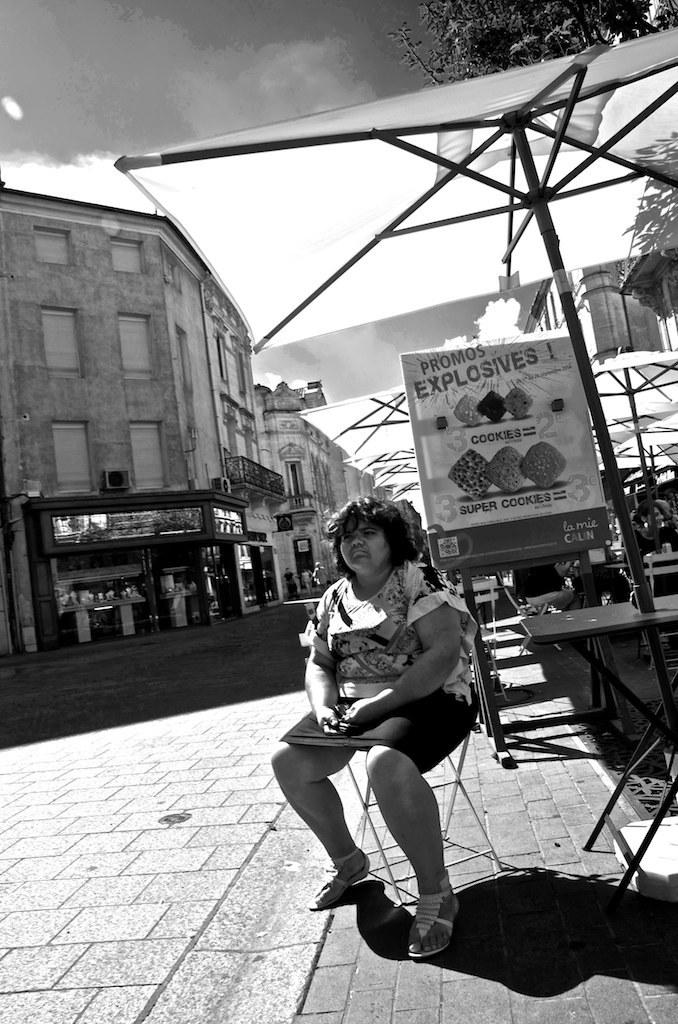What is the lady in the image doing? The lady is sitting on a chair in the image. What can be seen in the background of the image? There are banners, tents, buildings, tables and chairs, and trees in the background of the image. Can you see a toothbrush on the table in the image? There is no toothbrush present in the image. What direction is the lady facing in the image? The provided facts do not specify the direction the lady is facing, so it cannot be determined from the image. 